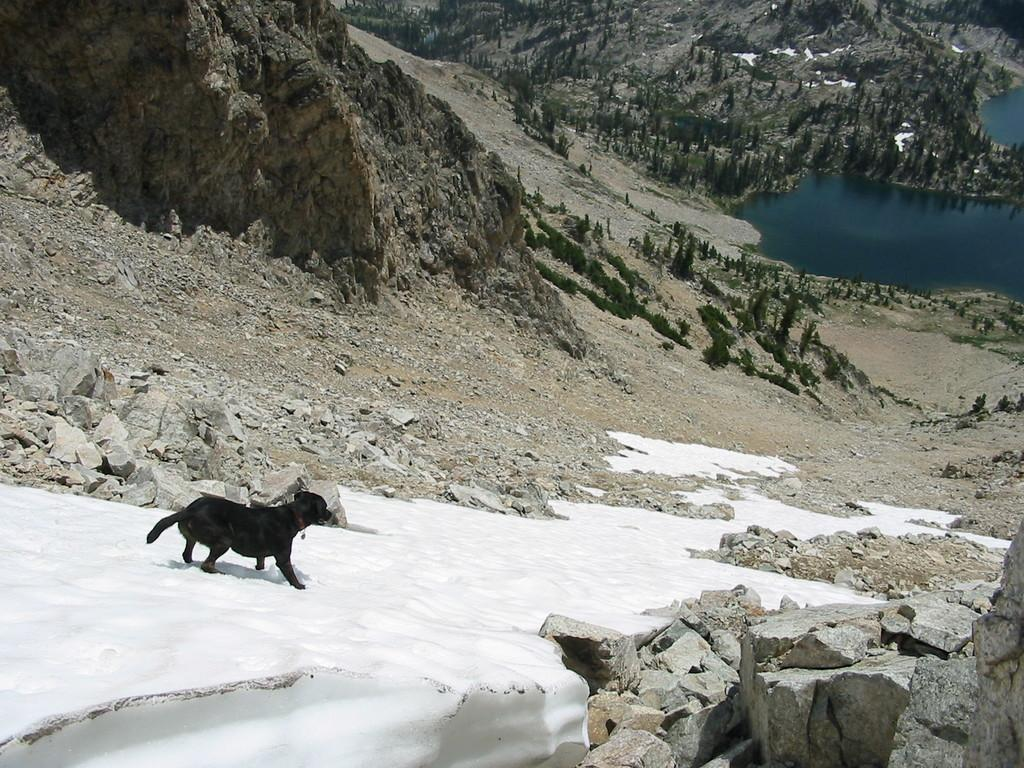What animal can be seen on the left side of the image? There is a dog on the left side of the image. What type of natural elements are present in the image? There are stones, trees, water, and falls in the image. Can you describe the location of the image? The location appears to be Iceland. How many cherries are hanging from the trees in the image? There are no cherries present in the image; the trees are not mentioned as having any fruit. Are there any bears visible in the image? There are no bears present in the image. 